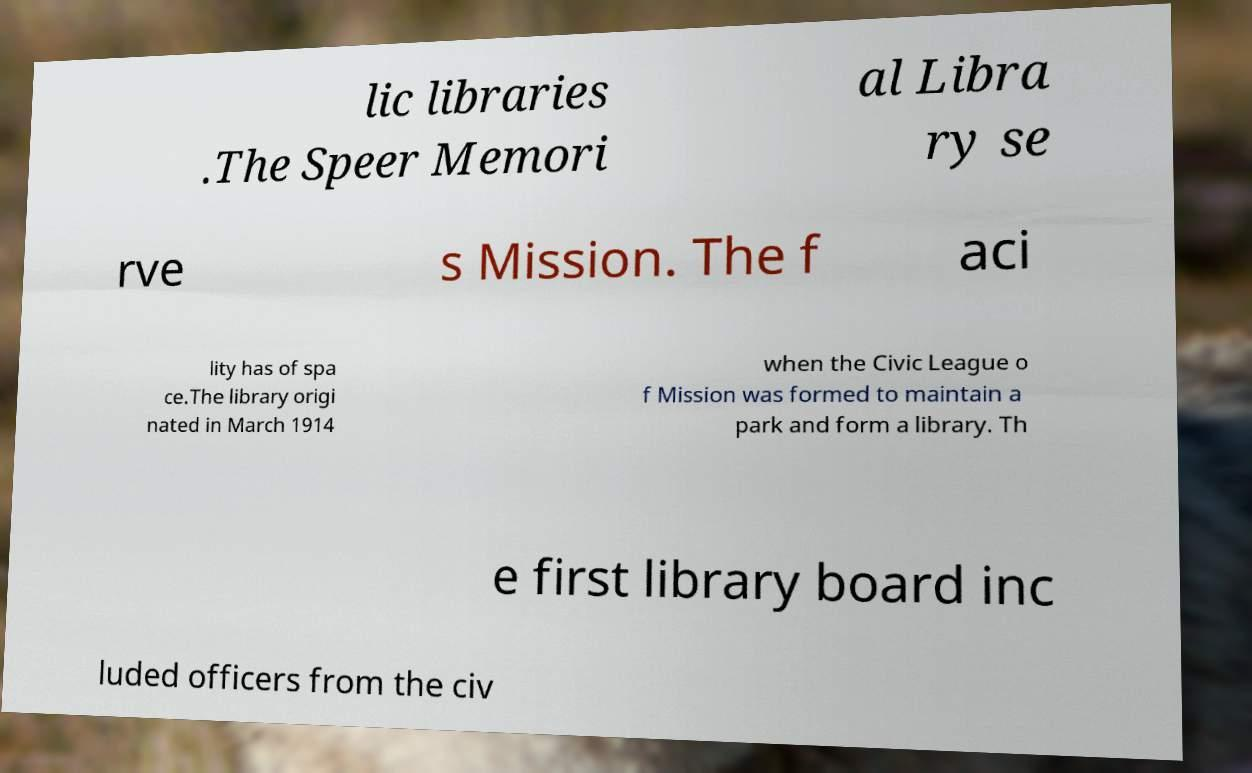Please read and relay the text visible in this image. What does it say? lic libraries .The Speer Memori al Libra ry se rve s Mission. The f aci lity has of spa ce.The library origi nated in March 1914 when the Civic League o f Mission was formed to maintain a park and form a library. Th e first library board inc luded officers from the civ 